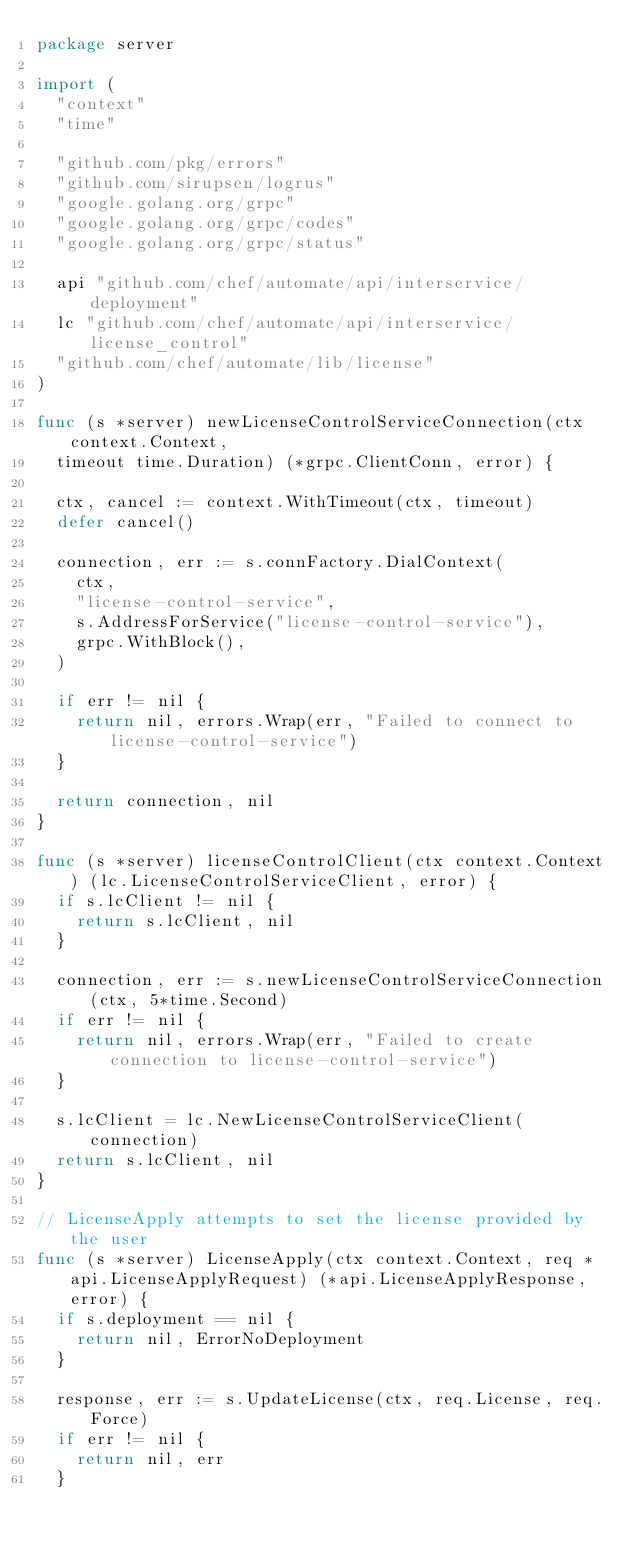<code> <loc_0><loc_0><loc_500><loc_500><_Go_>package server

import (
	"context"
	"time"

	"github.com/pkg/errors"
	"github.com/sirupsen/logrus"
	"google.golang.org/grpc"
	"google.golang.org/grpc/codes"
	"google.golang.org/grpc/status"

	api "github.com/chef/automate/api/interservice/deployment"
	lc "github.com/chef/automate/api/interservice/license_control"
	"github.com/chef/automate/lib/license"
)

func (s *server) newLicenseControlServiceConnection(ctx context.Context,
	timeout time.Duration) (*grpc.ClientConn, error) {

	ctx, cancel := context.WithTimeout(ctx, timeout)
	defer cancel()

	connection, err := s.connFactory.DialContext(
		ctx,
		"license-control-service",
		s.AddressForService("license-control-service"),
		grpc.WithBlock(),
	)

	if err != nil {
		return nil, errors.Wrap(err, "Failed to connect to license-control-service")
	}

	return connection, nil
}

func (s *server) licenseControlClient(ctx context.Context) (lc.LicenseControlServiceClient, error) {
	if s.lcClient != nil {
		return s.lcClient, nil
	}

	connection, err := s.newLicenseControlServiceConnection(ctx, 5*time.Second)
	if err != nil {
		return nil, errors.Wrap(err, "Failed to create connection to license-control-service")
	}

	s.lcClient = lc.NewLicenseControlServiceClient(connection)
	return s.lcClient, nil
}

// LicenseApply attempts to set the license provided by the user
func (s *server) LicenseApply(ctx context.Context, req *api.LicenseApplyRequest) (*api.LicenseApplyResponse, error) {
	if s.deployment == nil {
		return nil, ErrorNoDeployment
	}

	response, err := s.UpdateLicense(ctx, req.License, req.Force)
	if err != nil {
		return nil, err
	}
</code> 